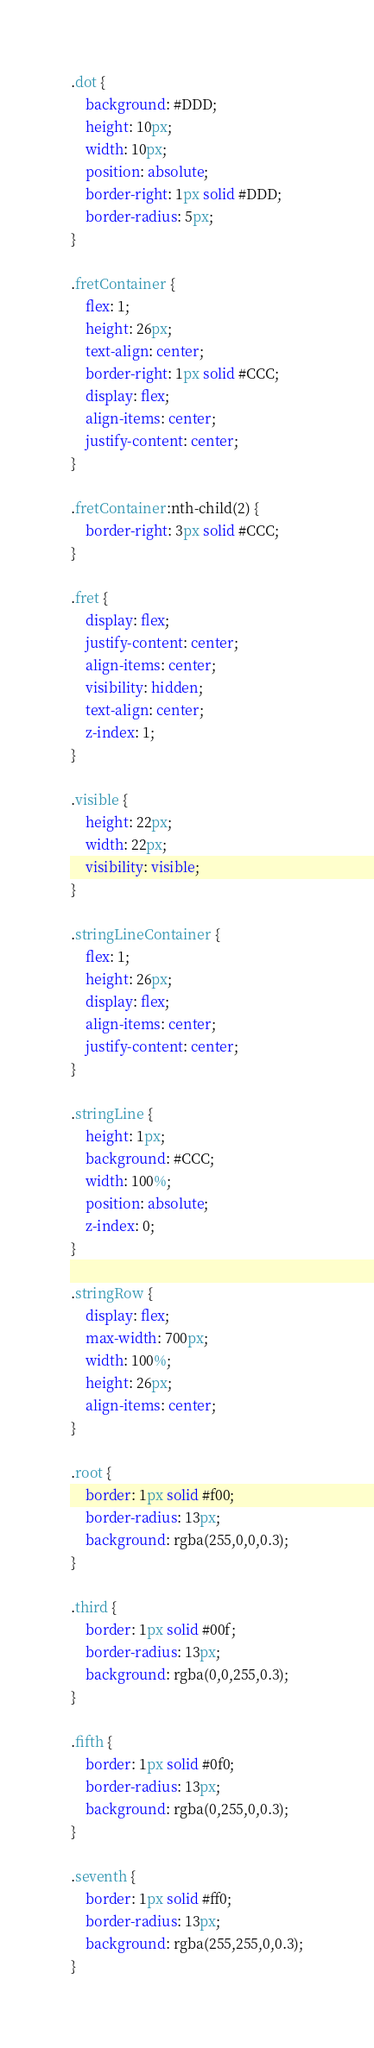<code> <loc_0><loc_0><loc_500><loc_500><_CSS_>.dot {
	background: #DDD; 
	height: 10px; 
	width: 10px; 
	position: absolute;
	border-right: 1px solid #DDD;
	border-radius: 5px;
}

.fretContainer {
	flex: 1;
	height: 26px;
	text-align: center;
	border-right: 1px solid #CCC;
	display: flex; 
	align-items: center;
	justify-content: center;	
}

.fretContainer:nth-child(2) {
	border-right: 3px solid #CCC;
}

.fret {
	display: flex;
	justify-content: center;
	align-items: center;
	visibility: hidden;
	text-align: center;
	z-index: 1;
}

.visible {
	height: 22px;
	width: 22px;
	visibility: visible;
}

.stringLineContainer {
	flex: 1;
	height: 26px;
	display: flex; 
	align-items: center;
	justify-content: center;	
}

.stringLine {
	height: 1px; 
	background: #CCC; 
	width: 100%; 
	position: absolute;
	z-index: 0;
}

.stringRow {
	display: flex; 
	max-width: 700px; 
	width: 100%; 
	height: 26px; 
	align-items: center;
}

.root {
	border: 1px solid #f00;
	border-radius: 13px;
	background: rgba(255,0,0,0.3);
}

.third {
	border: 1px solid #00f;
	border-radius: 13px;
	background: rgba(0,0,255,0.3);
}

.fifth {
	border: 1px solid #0f0;
	border-radius: 13px;
	background: rgba(0,255,0,0.3);
}

.seventh {
	border: 1px solid #ff0;
	border-radius: 13px;
	background: rgba(255,255,0,0.3);
}</code> 